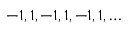<formula> <loc_0><loc_0><loc_500><loc_500>- 1 , 1 , - 1 , 1 , - 1 , 1 , \dots</formula> 